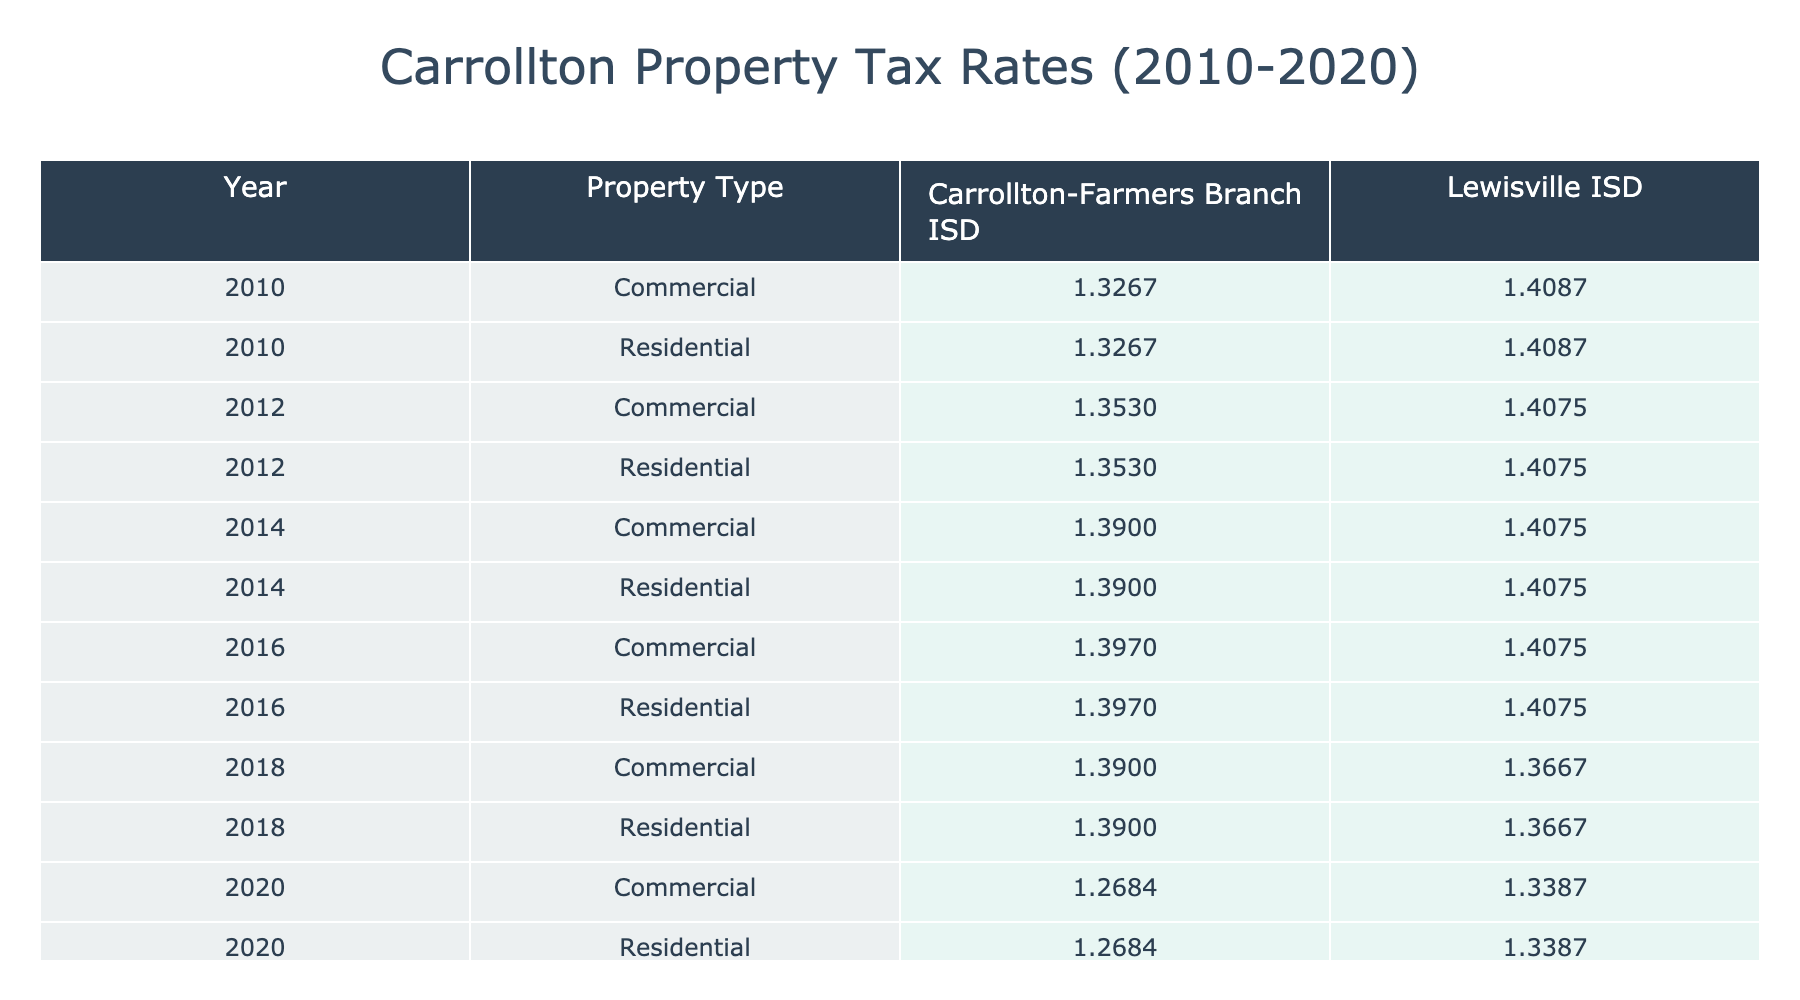What is the highest residential tax rate recorded in Lewisville ISD during the years shown? By examining the rows corresponding to residential properties in Lewisville ISD, the highest tax rate is 1.4087 for the year 2010.
Answer: 1.4087 Which district had a consistently lower tax rate for commercial properties over the years? By comparing the tax rates for commercial properties in both districts, Carrollton-Farmers Branch ISD had lower tax rates (1.3267 to 1.2684) compared to Lewisville ISD (1.4087 to 1.3387).
Answer: Carrollton-Farmers Branch ISD What was the average tax rate for residential properties in Carrollton-Farmers Branch ISD from 2010 to 2020? The rates for residential properties in Carrollton-Farmers Branch ISD are 1.3267, 1.3530, 1.3900, 1.3970, and 1.3900. The sum is 6.8570, and there are 5 data points. The average is 6.8570 / 5 = 1.3714.
Answer: 1.3714 Did the tax rate for commercial properties in Lewisville ISD decrease from 2010 to 2020? Comparing the commercial property tax rates for Lewisville ISD, they were 1.4087 in 2010 and decreased to 1.3387 in 2020, indicating a decrease over the years.
Answer: Yes What was the percentage drop in residential tax rates for Carrollton-Farmers Branch ISD from 2014 to 2020? The residential tax rate in Carrollton-Farmers Branch ISD was 1.3900 in 2014 and decreased to 1.2684 in 2020. The drop is 1.3900 - 1.2684 = 0.1216. To find the percentage drop: (0.1216 / 1.3900) * 100 ≈ 8.74%.
Answer: Approximately 8.74% What was the difference between the highest and lowest commercial tax rates in Carrollton-Farmers Branch ISD from 2010 to 2020? The highest commercial tax rate was 1.3267 in 2010 and the lowest was 1.2684 in 2020. The difference is 1.3267 - 1.2684 = 0.0583.
Answer: 0.0583 Which property type had the highest tax rate in 2016 in Lewisville ISD? In 2016, the tax rate for residential properties was 1.4075, while for commercial properties it was also 1.4075. Both types had the same highest rate in that year.
Answer: Both types (Residential and Commercial) 